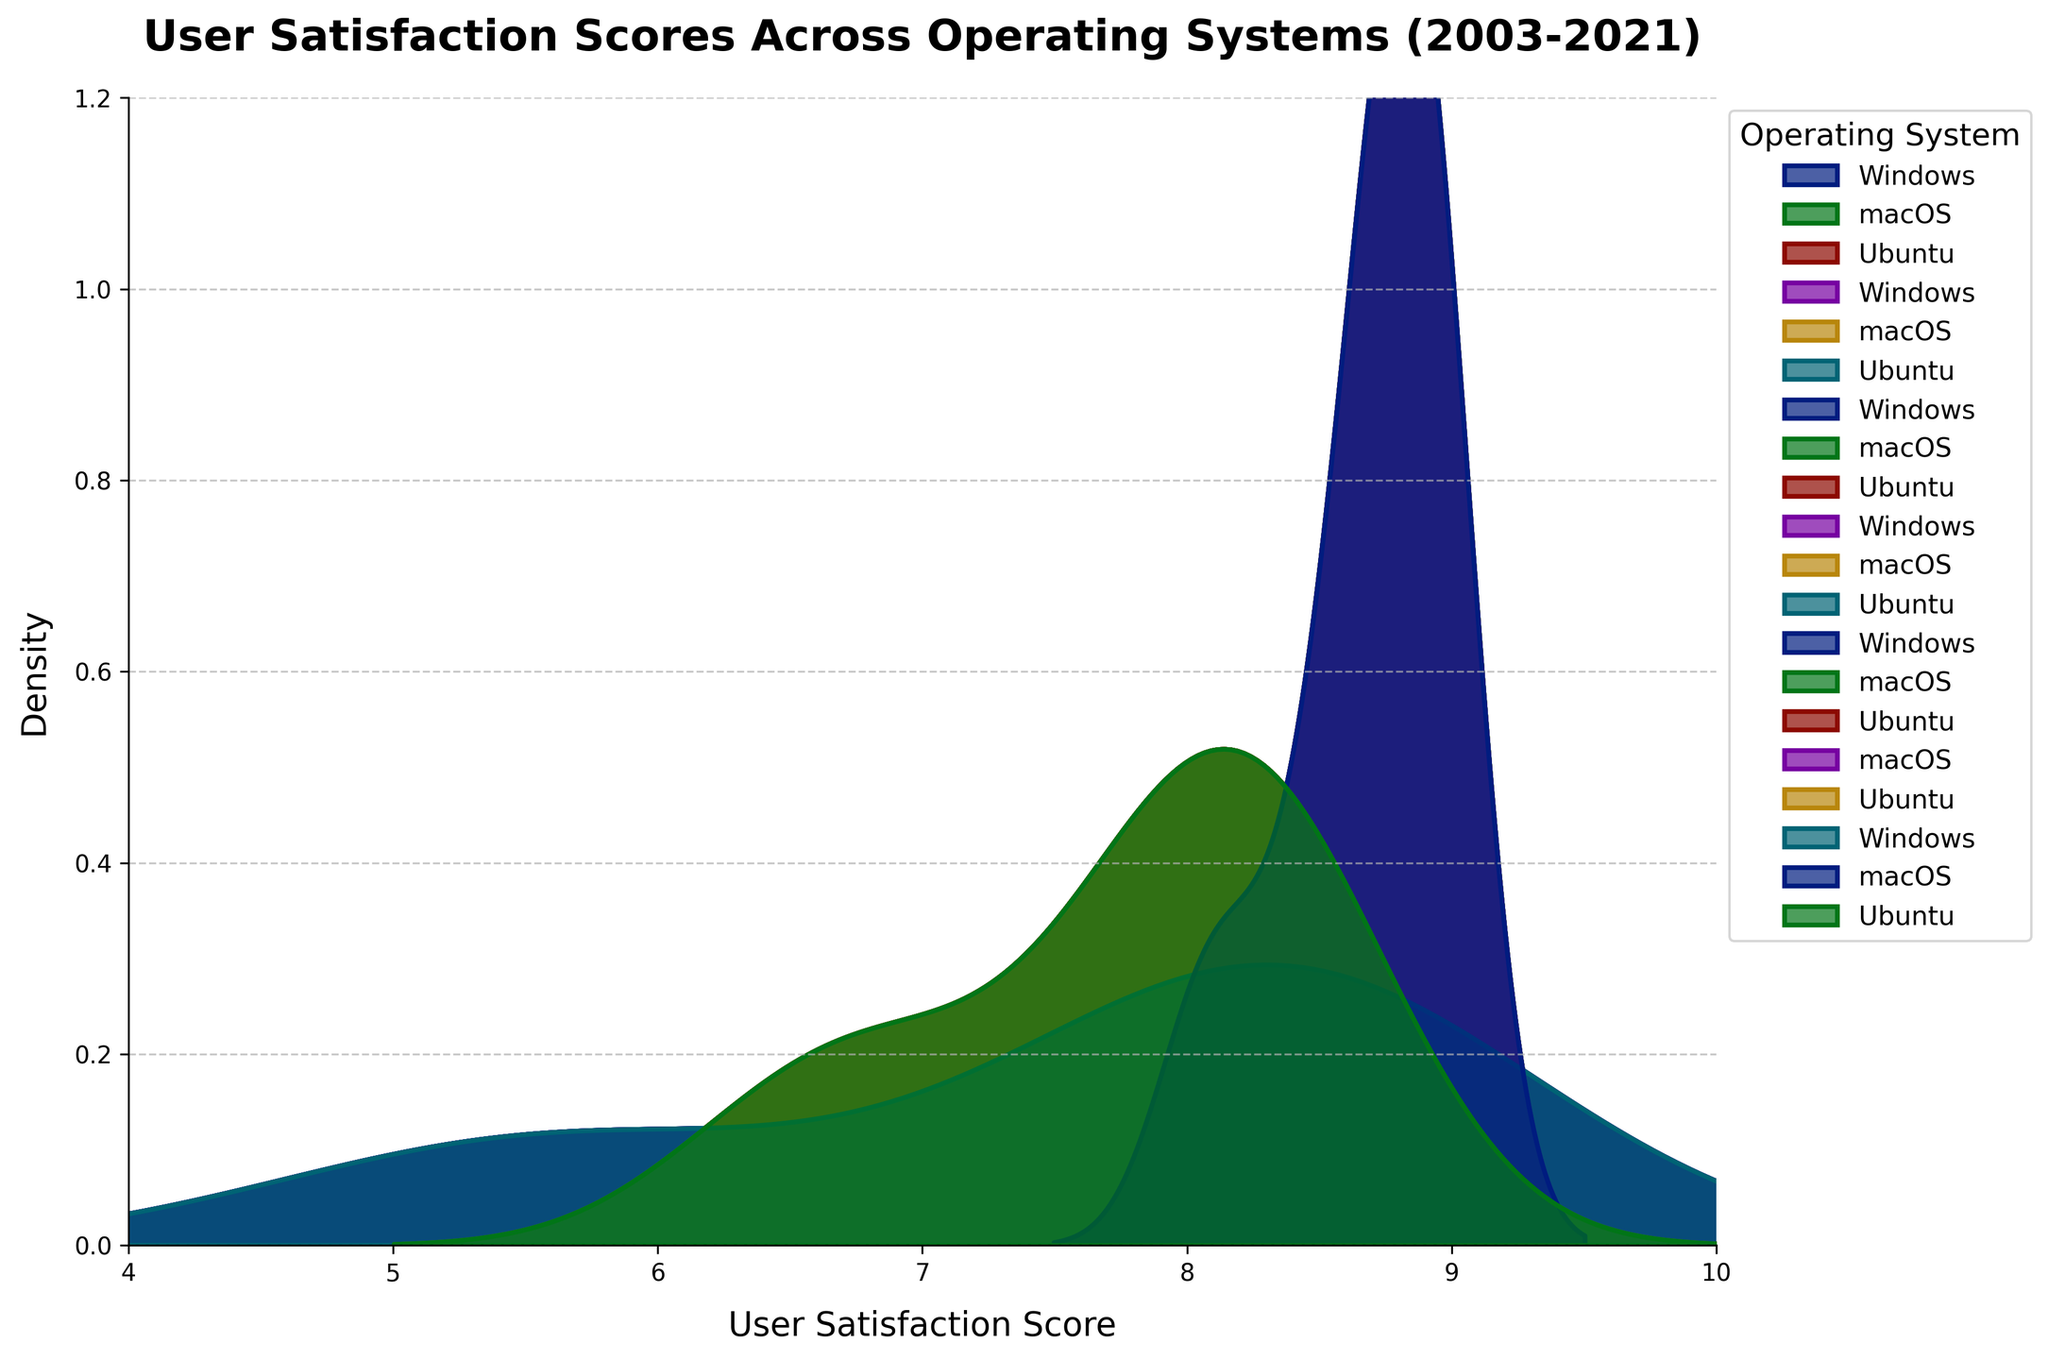What is the title of the plot? The title is usually placed at the top of the figure and specifies what the plot is about. Here, the title is visible above the plot area.
Answer: User Satisfaction Scores Across Operating Systems (2003-2021) Which operating system appears to have the highest peak density? By observing the plot, we look for the operating system distribution which has the tallest peak.
Answer: macOS What is the range of User Satisfaction Scores shown on the x-axis? The x-axis ranges specify the minimum and maximum values plotted. We can see this by looking at the limits of the x-axis.
Answer: 4 to 10 According to the plot, is the User Satisfaction Score distribution of Windows more spread out or more concentrated compared to Ubuntu? We compare the width of the distribution curves for Windows and Ubuntu. A more spread-out curve indicates more variation in scores, while a taller, narrower curve shows concentration around certain values.
Answer: More spread out How do the densities of macOS and Windows compare around the score of 8? We look at the height of the density curves for macOS and Windows at the User Satisfaction Score value of 8.
Answer: macOS has a higher density around the score of 8 Which operating system shows a significant improvement in user satisfaction from the early years (2003) to the latest years (2021)? We observe the shift in the peaks of the distributions for each operating system from left to right over time. A rightward shift indicates improvement.
Answer: Windows What does the highest density value on the y-axis represent? The y-axis represents the density of user satisfaction scores. The highest value on this axis depicts the maximum frequency (density) at which a certain score occurs in the data.
Answer: Approximately 1.2 Comparing the distributions, which operating system has the least variation in user satisfaction scores? Least variation is indicated by the narrowest and tallest KDE (Kernel Density Estimate) curve. We determine this by comparing the spread of the curves for each operating system.
Answer: macOS What trend is visible in the user satisfaction scores for Ubuntu over the years? We observe the relative positions and shapes of the density curves for Ubuntu across different time periods, noting any patterns or shifts.
Answer: Increasing trend Which operating systems show overlapping distributions, indicating similar user satisfaction scores? Overlapping distributions are identified by areas where the density curves for different operating systems partially or completely overlap. We compare the KDE curves to find these overlaps.
Answer: Windows and Ubuntu 